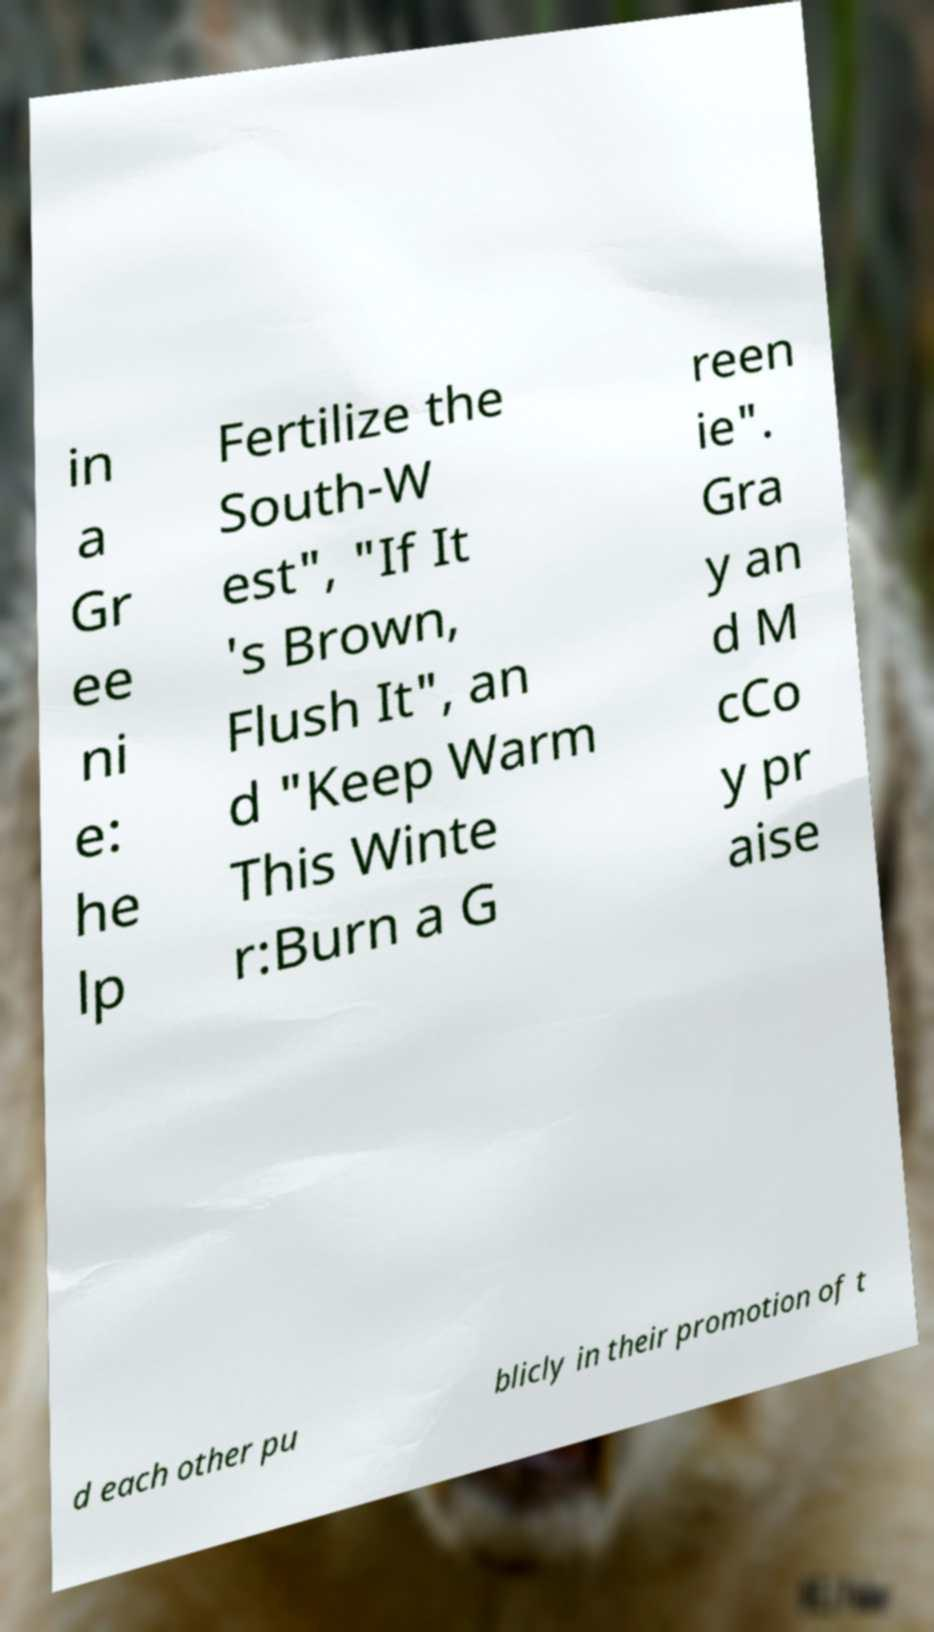Can you read and provide the text displayed in the image?This photo seems to have some interesting text. Can you extract and type it out for me? in a Gr ee ni e: he lp Fertilize the South-W est", "If It 's Brown, Flush It", an d "Keep Warm This Winte r:Burn a G reen ie". Gra y an d M cCo y pr aise d each other pu blicly in their promotion of t 